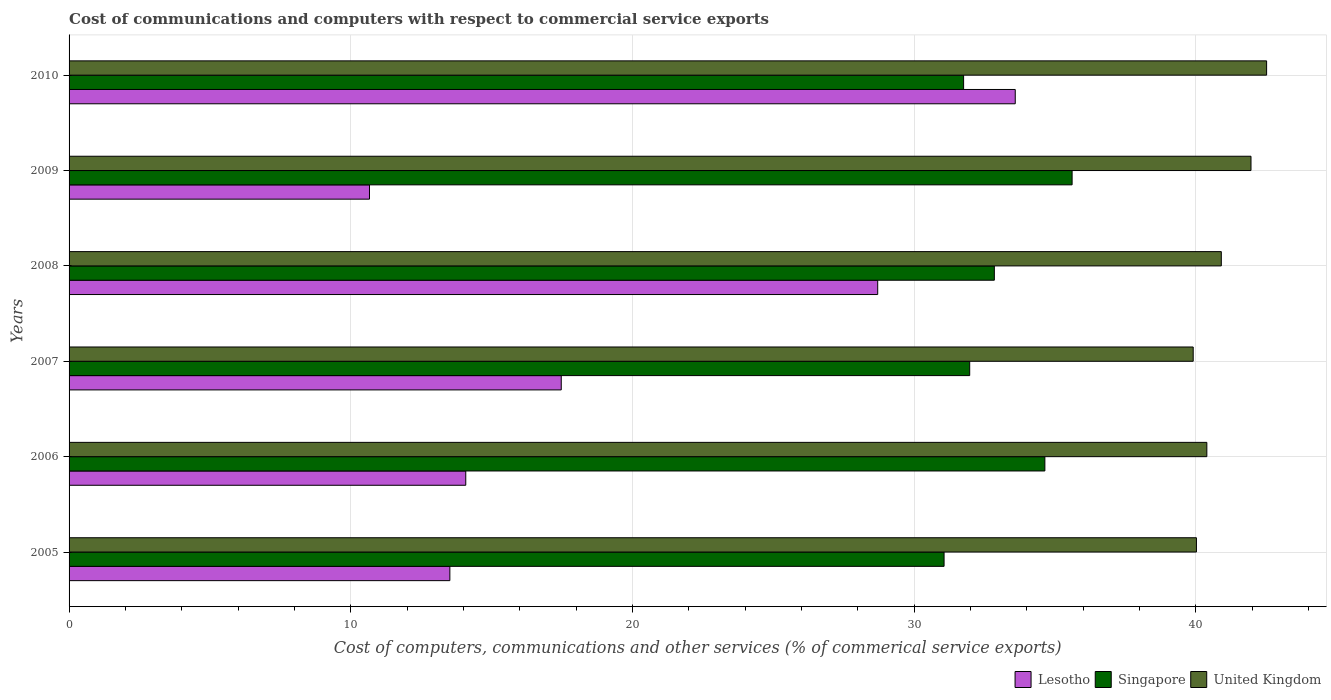How many groups of bars are there?
Your answer should be compact. 6. Are the number of bars on each tick of the Y-axis equal?
Ensure brevity in your answer.  Yes. What is the label of the 4th group of bars from the top?
Offer a terse response. 2007. What is the cost of communications and computers in United Kingdom in 2006?
Your answer should be compact. 40.39. Across all years, what is the maximum cost of communications and computers in Lesotho?
Give a very brief answer. 33.59. Across all years, what is the minimum cost of communications and computers in United Kingdom?
Your response must be concise. 39.91. In which year was the cost of communications and computers in United Kingdom minimum?
Provide a succinct answer. 2007. What is the total cost of communications and computers in Singapore in the graph?
Make the answer very short. 197.91. What is the difference between the cost of communications and computers in United Kingdom in 2007 and that in 2008?
Your response must be concise. -1. What is the difference between the cost of communications and computers in United Kingdom in 2005 and the cost of communications and computers in Singapore in 2008?
Make the answer very short. 7.17. What is the average cost of communications and computers in Lesotho per year?
Provide a succinct answer. 19.67. In the year 2007, what is the difference between the cost of communications and computers in United Kingdom and cost of communications and computers in Singapore?
Give a very brief answer. 7.93. In how many years, is the cost of communications and computers in Singapore greater than 16 %?
Offer a terse response. 6. What is the ratio of the cost of communications and computers in Singapore in 2005 to that in 2007?
Provide a short and direct response. 0.97. Is the cost of communications and computers in Lesotho in 2007 less than that in 2010?
Give a very brief answer. Yes. Is the difference between the cost of communications and computers in United Kingdom in 2007 and 2008 greater than the difference between the cost of communications and computers in Singapore in 2007 and 2008?
Make the answer very short. No. What is the difference between the highest and the second highest cost of communications and computers in Singapore?
Provide a short and direct response. 0.97. What is the difference between the highest and the lowest cost of communications and computers in Singapore?
Offer a terse response. 4.55. What does the 3rd bar from the top in 2008 represents?
Your answer should be very brief. Lesotho. What does the 3rd bar from the bottom in 2007 represents?
Offer a very short reply. United Kingdom. How many years are there in the graph?
Your response must be concise. 6. What is the difference between two consecutive major ticks on the X-axis?
Your answer should be very brief. 10. Are the values on the major ticks of X-axis written in scientific E-notation?
Make the answer very short. No. Does the graph contain any zero values?
Offer a terse response. No. Where does the legend appear in the graph?
Offer a very short reply. Bottom right. How are the legend labels stacked?
Your response must be concise. Horizontal. What is the title of the graph?
Provide a succinct answer. Cost of communications and computers with respect to commercial service exports. What is the label or title of the X-axis?
Your answer should be very brief. Cost of computers, communications and other services (% of commerical service exports). What is the label or title of the Y-axis?
Your response must be concise. Years. What is the Cost of computers, communications and other services (% of commerical service exports) of Lesotho in 2005?
Your response must be concise. 13.52. What is the Cost of computers, communications and other services (% of commerical service exports) of Singapore in 2005?
Provide a short and direct response. 31.07. What is the Cost of computers, communications and other services (% of commerical service exports) in United Kingdom in 2005?
Offer a very short reply. 40.03. What is the Cost of computers, communications and other services (% of commerical service exports) in Lesotho in 2006?
Your response must be concise. 14.08. What is the Cost of computers, communications and other services (% of commerical service exports) in Singapore in 2006?
Ensure brevity in your answer.  34.64. What is the Cost of computers, communications and other services (% of commerical service exports) of United Kingdom in 2006?
Make the answer very short. 40.39. What is the Cost of computers, communications and other services (% of commerical service exports) in Lesotho in 2007?
Provide a short and direct response. 17.47. What is the Cost of computers, communications and other services (% of commerical service exports) in Singapore in 2007?
Offer a terse response. 31.98. What is the Cost of computers, communications and other services (% of commerical service exports) in United Kingdom in 2007?
Your answer should be compact. 39.91. What is the Cost of computers, communications and other services (% of commerical service exports) in Lesotho in 2008?
Offer a terse response. 28.71. What is the Cost of computers, communications and other services (% of commerical service exports) in Singapore in 2008?
Offer a very short reply. 32.85. What is the Cost of computers, communications and other services (% of commerical service exports) of United Kingdom in 2008?
Keep it short and to the point. 40.91. What is the Cost of computers, communications and other services (% of commerical service exports) in Lesotho in 2009?
Offer a terse response. 10.67. What is the Cost of computers, communications and other services (% of commerical service exports) in Singapore in 2009?
Ensure brevity in your answer.  35.61. What is the Cost of computers, communications and other services (% of commerical service exports) of United Kingdom in 2009?
Provide a succinct answer. 41.96. What is the Cost of computers, communications and other services (% of commerical service exports) in Lesotho in 2010?
Give a very brief answer. 33.59. What is the Cost of computers, communications and other services (% of commerical service exports) in Singapore in 2010?
Provide a short and direct response. 31.76. What is the Cost of computers, communications and other services (% of commerical service exports) of United Kingdom in 2010?
Ensure brevity in your answer.  42.52. Across all years, what is the maximum Cost of computers, communications and other services (% of commerical service exports) of Lesotho?
Give a very brief answer. 33.59. Across all years, what is the maximum Cost of computers, communications and other services (% of commerical service exports) of Singapore?
Offer a terse response. 35.61. Across all years, what is the maximum Cost of computers, communications and other services (% of commerical service exports) in United Kingdom?
Your answer should be compact. 42.52. Across all years, what is the minimum Cost of computers, communications and other services (% of commerical service exports) in Lesotho?
Ensure brevity in your answer.  10.67. Across all years, what is the minimum Cost of computers, communications and other services (% of commerical service exports) in Singapore?
Make the answer very short. 31.07. Across all years, what is the minimum Cost of computers, communications and other services (% of commerical service exports) of United Kingdom?
Ensure brevity in your answer.  39.91. What is the total Cost of computers, communications and other services (% of commerical service exports) in Lesotho in the graph?
Offer a very short reply. 118.04. What is the total Cost of computers, communications and other services (% of commerical service exports) in Singapore in the graph?
Give a very brief answer. 197.91. What is the total Cost of computers, communications and other services (% of commerical service exports) of United Kingdom in the graph?
Provide a succinct answer. 245.72. What is the difference between the Cost of computers, communications and other services (% of commerical service exports) of Lesotho in 2005 and that in 2006?
Give a very brief answer. -0.56. What is the difference between the Cost of computers, communications and other services (% of commerical service exports) in Singapore in 2005 and that in 2006?
Ensure brevity in your answer.  -3.58. What is the difference between the Cost of computers, communications and other services (% of commerical service exports) in United Kingdom in 2005 and that in 2006?
Ensure brevity in your answer.  -0.37. What is the difference between the Cost of computers, communications and other services (% of commerical service exports) of Lesotho in 2005 and that in 2007?
Provide a succinct answer. -3.95. What is the difference between the Cost of computers, communications and other services (% of commerical service exports) of Singapore in 2005 and that in 2007?
Keep it short and to the point. -0.91. What is the difference between the Cost of computers, communications and other services (% of commerical service exports) of United Kingdom in 2005 and that in 2007?
Ensure brevity in your answer.  0.12. What is the difference between the Cost of computers, communications and other services (% of commerical service exports) in Lesotho in 2005 and that in 2008?
Make the answer very short. -15.19. What is the difference between the Cost of computers, communications and other services (% of commerical service exports) of Singapore in 2005 and that in 2008?
Give a very brief answer. -1.78. What is the difference between the Cost of computers, communications and other services (% of commerical service exports) of United Kingdom in 2005 and that in 2008?
Provide a short and direct response. -0.88. What is the difference between the Cost of computers, communications and other services (% of commerical service exports) in Lesotho in 2005 and that in 2009?
Your answer should be very brief. 2.85. What is the difference between the Cost of computers, communications and other services (% of commerical service exports) in Singapore in 2005 and that in 2009?
Provide a succinct answer. -4.55. What is the difference between the Cost of computers, communications and other services (% of commerical service exports) of United Kingdom in 2005 and that in 2009?
Keep it short and to the point. -1.94. What is the difference between the Cost of computers, communications and other services (% of commerical service exports) in Lesotho in 2005 and that in 2010?
Provide a short and direct response. -20.07. What is the difference between the Cost of computers, communications and other services (% of commerical service exports) of Singapore in 2005 and that in 2010?
Ensure brevity in your answer.  -0.69. What is the difference between the Cost of computers, communications and other services (% of commerical service exports) of United Kingdom in 2005 and that in 2010?
Offer a terse response. -2.49. What is the difference between the Cost of computers, communications and other services (% of commerical service exports) in Lesotho in 2006 and that in 2007?
Give a very brief answer. -3.39. What is the difference between the Cost of computers, communications and other services (% of commerical service exports) of Singapore in 2006 and that in 2007?
Offer a very short reply. 2.67. What is the difference between the Cost of computers, communications and other services (% of commerical service exports) of United Kingdom in 2006 and that in 2007?
Provide a succinct answer. 0.48. What is the difference between the Cost of computers, communications and other services (% of commerical service exports) of Lesotho in 2006 and that in 2008?
Your response must be concise. -14.62. What is the difference between the Cost of computers, communications and other services (% of commerical service exports) in Singapore in 2006 and that in 2008?
Your answer should be very brief. 1.79. What is the difference between the Cost of computers, communications and other services (% of commerical service exports) of United Kingdom in 2006 and that in 2008?
Offer a very short reply. -0.51. What is the difference between the Cost of computers, communications and other services (% of commerical service exports) of Lesotho in 2006 and that in 2009?
Give a very brief answer. 3.42. What is the difference between the Cost of computers, communications and other services (% of commerical service exports) of Singapore in 2006 and that in 2009?
Ensure brevity in your answer.  -0.97. What is the difference between the Cost of computers, communications and other services (% of commerical service exports) of United Kingdom in 2006 and that in 2009?
Your answer should be compact. -1.57. What is the difference between the Cost of computers, communications and other services (% of commerical service exports) in Lesotho in 2006 and that in 2010?
Keep it short and to the point. -19.51. What is the difference between the Cost of computers, communications and other services (% of commerical service exports) in Singapore in 2006 and that in 2010?
Your answer should be compact. 2.89. What is the difference between the Cost of computers, communications and other services (% of commerical service exports) in United Kingdom in 2006 and that in 2010?
Offer a very short reply. -2.12. What is the difference between the Cost of computers, communications and other services (% of commerical service exports) in Lesotho in 2007 and that in 2008?
Offer a terse response. -11.24. What is the difference between the Cost of computers, communications and other services (% of commerical service exports) of Singapore in 2007 and that in 2008?
Give a very brief answer. -0.88. What is the difference between the Cost of computers, communications and other services (% of commerical service exports) of United Kingdom in 2007 and that in 2008?
Provide a succinct answer. -1. What is the difference between the Cost of computers, communications and other services (% of commerical service exports) in Lesotho in 2007 and that in 2009?
Offer a terse response. 6.81. What is the difference between the Cost of computers, communications and other services (% of commerical service exports) of Singapore in 2007 and that in 2009?
Offer a very short reply. -3.64. What is the difference between the Cost of computers, communications and other services (% of commerical service exports) in United Kingdom in 2007 and that in 2009?
Provide a short and direct response. -2.05. What is the difference between the Cost of computers, communications and other services (% of commerical service exports) in Lesotho in 2007 and that in 2010?
Ensure brevity in your answer.  -16.12. What is the difference between the Cost of computers, communications and other services (% of commerical service exports) in Singapore in 2007 and that in 2010?
Your answer should be very brief. 0.22. What is the difference between the Cost of computers, communications and other services (% of commerical service exports) of United Kingdom in 2007 and that in 2010?
Provide a succinct answer. -2.61. What is the difference between the Cost of computers, communications and other services (% of commerical service exports) in Lesotho in 2008 and that in 2009?
Offer a terse response. 18.04. What is the difference between the Cost of computers, communications and other services (% of commerical service exports) in Singapore in 2008 and that in 2009?
Your response must be concise. -2.76. What is the difference between the Cost of computers, communications and other services (% of commerical service exports) in United Kingdom in 2008 and that in 2009?
Keep it short and to the point. -1.05. What is the difference between the Cost of computers, communications and other services (% of commerical service exports) of Lesotho in 2008 and that in 2010?
Provide a short and direct response. -4.88. What is the difference between the Cost of computers, communications and other services (% of commerical service exports) of Singapore in 2008 and that in 2010?
Your response must be concise. 1.09. What is the difference between the Cost of computers, communications and other services (% of commerical service exports) of United Kingdom in 2008 and that in 2010?
Your answer should be compact. -1.61. What is the difference between the Cost of computers, communications and other services (% of commerical service exports) of Lesotho in 2009 and that in 2010?
Keep it short and to the point. -22.93. What is the difference between the Cost of computers, communications and other services (% of commerical service exports) in Singapore in 2009 and that in 2010?
Your response must be concise. 3.85. What is the difference between the Cost of computers, communications and other services (% of commerical service exports) of United Kingdom in 2009 and that in 2010?
Offer a terse response. -0.55. What is the difference between the Cost of computers, communications and other services (% of commerical service exports) of Lesotho in 2005 and the Cost of computers, communications and other services (% of commerical service exports) of Singapore in 2006?
Give a very brief answer. -21.13. What is the difference between the Cost of computers, communications and other services (% of commerical service exports) in Lesotho in 2005 and the Cost of computers, communications and other services (% of commerical service exports) in United Kingdom in 2006?
Offer a very short reply. -26.88. What is the difference between the Cost of computers, communications and other services (% of commerical service exports) of Singapore in 2005 and the Cost of computers, communications and other services (% of commerical service exports) of United Kingdom in 2006?
Your answer should be compact. -9.33. What is the difference between the Cost of computers, communications and other services (% of commerical service exports) in Lesotho in 2005 and the Cost of computers, communications and other services (% of commerical service exports) in Singapore in 2007?
Provide a succinct answer. -18.46. What is the difference between the Cost of computers, communications and other services (% of commerical service exports) of Lesotho in 2005 and the Cost of computers, communications and other services (% of commerical service exports) of United Kingdom in 2007?
Offer a very short reply. -26.39. What is the difference between the Cost of computers, communications and other services (% of commerical service exports) of Singapore in 2005 and the Cost of computers, communications and other services (% of commerical service exports) of United Kingdom in 2007?
Provide a short and direct response. -8.84. What is the difference between the Cost of computers, communications and other services (% of commerical service exports) of Lesotho in 2005 and the Cost of computers, communications and other services (% of commerical service exports) of Singapore in 2008?
Make the answer very short. -19.33. What is the difference between the Cost of computers, communications and other services (% of commerical service exports) in Lesotho in 2005 and the Cost of computers, communications and other services (% of commerical service exports) in United Kingdom in 2008?
Your answer should be very brief. -27.39. What is the difference between the Cost of computers, communications and other services (% of commerical service exports) in Singapore in 2005 and the Cost of computers, communications and other services (% of commerical service exports) in United Kingdom in 2008?
Your answer should be compact. -9.84. What is the difference between the Cost of computers, communications and other services (% of commerical service exports) of Lesotho in 2005 and the Cost of computers, communications and other services (% of commerical service exports) of Singapore in 2009?
Make the answer very short. -22.09. What is the difference between the Cost of computers, communications and other services (% of commerical service exports) of Lesotho in 2005 and the Cost of computers, communications and other services (% of commerical service exports) of United Kingdom in 2009?
Provide a succinct answer. -28.44. What is the difference between the Cost of computers, communications and other services (% of commerical service exports) in Singapore in 2005 and the Cost of computers, communications and other services (% of commerical service exports) in United Kingdom in 2009?
Provide a short and direct response. -10.9. What is the difference between the Cost of computers, communications and other services (% of commerical service exports) of Lesotho in 2005 and the Cost of computers, communications and other services (% of commerical service exports) of Singapore in 2010?
Make the answer very short. -18.24. What is the difference between the Cost of computers, communications and other services (% of commerical service exports) in Lesotho in 2005 and the Cost of computers, communications and other services (% of commerical service exports) in United Kingdom in 2010?
Make the answer very short. -29. What is the difference between the Cost of computers, communications and other services (% of commerical service exports) of Singapore in 2005 and the Cost of computers, communications and other services (% of commerical service exports) of United Kingdom in 2010?
Make the answer very short. -11.45. What is the difference between the Cost of computers, communications and other services (% of commerical service exports) in Lesotho in 2006 and the Cost of computers, communications and other services (% of commerical service exports) in Singapore in 2007?
Make the answer very short. -17.89. What is the difference between the Cost of computers, communications and other services (% of commerical service exports) in Lesotho in 2006 and the Cost of computers, communications and other services (% of commerical service exports) in United Kingdom in 2007?
Your answer should be very brief. -25.83. What is the difference between the Cost of computers, communications and other services (% of commerical service exports) in Singapore in 2006 and the Cost of computers, communications and other services (% of commerical service exports) in United Kingdom in 2007?
Ensure brevity in your answer.  -5.27. What is the difference between the Cost of computers, communications and other services (% of commerical service exports) of Lesotho in 2006 and the Cost of computers, communications and other services (% of commerical service exports) of Singapore in 2008?
Your answer should be very brief. -18.77. What is the difference between the Cost of computers, communications and other services (% of commerical service exports) in Lesotho in 2006 and the Cost of computers, communications and other services (% of commerical service exports) in United Kingdom in 2008?
Provide a succinct answer. -26.82. What is the difference between the Cost of computers, communications and other services (% of commerical service exports) of Singapore in 2006 and the Cost of computers, communications and other services (% of commerical service exports) of United Kingdom in 2008?
Your answer should be very brief. -6.26. What is the difference between the Cost of computers, communications and other services (% of commerical service exports) in Lesotho in 2006 and the Cost of computers, communications and other services (% of commerical service exports) in Singapore in 2009?
Your response must be concise. -21.53. What is the difference between the Cost of computers, communications and other services (% of commerical service exports) in Lesotho in 2006 and the Cost of computers, communications and other services (% of commerical service exports) in United Kingdom in 2009?
Ensure brevity in your answer.  -27.88. What is the difference between the Cost of computers, communications and other services (% of commerical service exports) in Singapore in 2006 and the Cost of computers, communications and other services (% of commerical service exports) in United Kingdom in 2009?
Offer a terse response. -7.32. What is the difference between the Cost of computers, communications and other services (% of commerical service exports) of Lesotho in 2006 and the Cost of computers, communications and other services (% of commerical service exports) of Singapore in 2010?
Provide a short and direct response. -17.68. What is the difference between the Cost of computers, communications and other services (% of commerical service exports) in Lesotho in 2006 and the Cost of computers, communications and other services (% of commerical service exports) in United Kingdom in 2010?
Offer a very short reply. -28.43. What is the difference between the Cost of computers, communications and other services (% of commerical service exports) of Singapore in 2006 and the Cost of computers, communications and other services (% of commerical service exports) of United Kingdom in 2010?
Your answer should be very brief. -7.87. What is the difference between the Cost of computers, communications and other services (% of commerical service exports) in Lesotho in 2007 and the Cost of computers, communications and other services (% of commerical service exports) in Singapore in 2008?
Your answer should be very brief. -15.38. What is the difference between the Cost of computers, communications and other services (% of commerical service exports) in Lesotho in 2007 and the Cost of computers, communications and other services (% of commerical service exports) in United Kingdom in 2008?
Keep it short and to the point. -23.43. What is the difference between the Cost of computers, communications and other services (% of commerical service exports) of Singapore in 2007 and the Cost of computers, communications and other services (% of commerical service exports) of United Kingdom in 2008?
Ensure brevity in your answer.  -8.93. What is the difference between the Cost of computers, communications and other services (% of commerical service exports) of Lesotho in 2007 and the Cost of computers, communications and other services (% of commerical service exports) of Singapore in 2009?
Ensure brevity in your answer.  -18.14. What is the difference between the Cost of computers, communications and other services (% of commerical service exports) of Lesotho in 2007 and the Cost of computers, communications and other services (% of commerical service exports) of United Kingdom in 2009?
Your answer should be compact. -24.49. What is the difference between the Cost of computers, communications and other services (% of commerical service exports) in Singapore in 2007 and the Cost of computers, communications and other services (% of commerical service exports) in United Kingdom in 2009?
Make the answer very short. -9.99. What is the difference between the Cost of computers, communications and other services (% of commerical service exports) in Lesotho in 2007 and the Cost of computers, communications and other services (% of commerical service exports) in Singapore in 2010?
Your response must be concise. -14.29. What is the difference between the Cost of computers, communications and other services (% of commerical service exports) of Lesotho in 2007 and the Cost of computers, communications and other services (% of commerical service exports) of United Kingdom in 2010?
Your response must be concise. -25.04. What is the difference between the Cost of computers, communications and other services (% of commerical service exports) in Singapore in 2007 and the Cost of computers, communications and other services (% of commerical service exports) in United Kingdom in 2010?
Provide a succinct answer. -10.54. What is the difference between the Cost of computers, communications and other services (% of commerical service exports) of Lesotho in 2008 and the Cost of computers, communications and other services (% of commerical service exports) of Singapore in 2009?
Make the answer very short. -6.9. What is the difference between the Cost of computers, communications and other services (% of commerical service exports) in Lesotho in 2008 and the Cost of computers, communications and other services (% of commerical service exports) in United Kingdom in 2009?
Make the answer very short. -13.25. What is the difference between the Cost of computers, communications and other services (% of commerical service exports) of Singapore in 2008 and the Cost of computers, communications and other services (% of commerical service exports) of United Kingdom in 2009?
Provide a succinct answer. -9.11. What is the difference between the Cost of computers, communications and other services (% of commerical service exports) in Lesotho in 2008 and the Cost of computers, communications and other services (% of commerical service exports) in Singapore in 2010?
Your answer should be very brief. -3.05. What is the difference between the Cost of computers, communications and other services (% of commerical service exports) in Lesotho in 2008 and the Cost of computers, communications and other services (% of commerical service exports) in United Kingdom in 2010?
Provide a short and direct response. -13.81. What is the difference between the Cost of computers, communications and other services (% of commerical service exports) in Singapore in 2008 and the Cost of computers, communications and other services (% of commerical service exports) in United Kingdom in 2010?
Provide a succinct answer. -9.67. What is the difference between the Cost of computers, communications and other services (% of commerical service exports) of Lesotho in 2009 and the Cost of computers, communications and other services (% of commerical service exports) of Singapore in 2010?
Ensure brevity in your answer.  -21.09. What is the difference between the Cost of computers, communications and other services (% of commerical service exports) of Lesotho in 2009 and the Cost of computers, communications and other services (% of commerical service exports) of United Kingdom in 2010?
Your answer should be compact. -31.85. What is the difference between the Cost of computers, communications and other services (% of commerical service exports) in Singapore in 2009 and the Cost of computers, communications and other services (% of commerical service exports) in United Kingdom in 2010?
Provide a succinct answer. -6.91. What is the average Cost of computers, communications and other services (% of commerical service exports) in Lesotho per year?
Your answer should be very brief. 19.67. What is the average Cost of computers, communications and other services (% of commerical service exports) in Singapore per year?
Make the answer very short. 32.98. What is the average Cost of computers, communications and other services (% of commerical service exports) of United Kingdom per year?
Offer a terse response. 40.95. In the year 2005, what is the difference between the Cost of computers, communications and other services (% of commerical service exports) of Lesotho and Cost of computers, communications and other services (% of commerical service exports) of Singapore?
Your answer should be compact. -17.55. In the year 2005, what is the difference between the Cost of computers, communications and other services (% of commerical service exports) of Lesotho and Cost of computers, communications and other services (% of commerical service exports) of United Kingdom?
Provide a succinct answer. -26.51. In the year 2005, what is the difference between the Cost of computers, communications and other services (% of commerical service exports) in Singapore and Cost of computers, communications and other services (% of commerical service exports) in United Kingdom?
Provide a short and direct response. -8.96. In the year 2006, what is the difference between the Cost of computers, communications and other services (% of commerical service exports) of Lesotho and Cost of computers, communications and other services (% of commerical service exports) of Singapore?
Make the answer very short. -20.56. In the year 2006, what is the difference between the Cost of computers, communications and other services (% of commerical service exports) of Lesotho and Cost of computers, communications and other services (% of commerical service exports) of United Kingdom?
Offer a very short reply. -26.31. In the year 2006, what is the difference between the Cost of computers, communications and other services (% of commerical service exports) in Singapore and Cost of computers, communications and other services (% of commerical service exports) in United Kingdom?
Make the answer very short. -5.75. In the year 2007, what is the difference between the Cost of computers, communications and other services (% of commerical service exports) of Lesotho and Cost of computers, communications and other services (% of commerical service exports) of Singapore?
Keep it short and to the point. -14.5. In the year 2007, what is the difference between the Cost of computers, communications and other services (% of commerical service exports) in Lesotho and Cost of computers, communications and other services (% of commerical service exports) in United Kingdom?
Give a very brief answer. -22.44. In the year 2007, what is the difference between the Cost of computers, communications and other services (% of commerical service exports) of Singapore and Cost of computers, communications and other services (% of commerical service exports) of United Kingdom?
Your response must be concise. -7.93. In the year 2008, what is the difference between the Cost of computers, communications and other services (% of commerical service exports) in Lesotho and Cost of computers, communications and other services (% of commerical service exports) in Singapore?
Make the answer very short. -4.14. In the year 2008, what is the difference between the Cost of computers, communications and other services (% of commerical service exports) in Lesotho and Cost of computers, communications and other services (% of commerical service exports) in United Kingdom?
Make the answer very short. -12.2. In the year 2008, what is the difference between the Cost of computers, communications and other services (% of commerical service exports) in Singapore and Cost of computers, communications and other services (% of commerical service exports) in United Kingdom?
Give a very brief answer. -8.06. In the year 2009, what is the difference between the Cost of computers, communications and other services (% of commerical service exports) in Lesotho and Cost of computers, communications and other services (% of commerical service exports) in Singapore?
Offer a very short reply. -24.95. In the year 2009, what is the difference between the Cost of computers, communications and other services (% of commerical service exports) of Lesotho and Cost of computers, communications and other services (% of commerical service exports) of United Kingdom?
Keep it short and to the point. -31.3. In the year 2009, what is the difference between the Cost of computers, communications and other services (% of commerical service exports) in Singapore and Cost of computers, communications and other services (% of commerical service exports) in United Kingdom?
Offer a very short reply. -6.35. In the year 2010, what is the difference between the Cost of computers, communications and other services (% of commerical service exports) of Lesotho and Cost of computers, communications and other services (% of commerical service exports) of Singapore?
Offer a very short reply. 1.83. In the year 2010, what is the difference between the Cost of computers, communications and other services (% of commerical service exports) in Lesotho and Cost of computers, communications and other services (% of commerical service exports) in United Kingdom?
Provide a succinct answer. -8.92. In the year 2010, what is the difference between the Cost of computers, communications and other services (% of commerical service exports) of Singapore and Cost of computers, communications and other services (% of commerical service exports) of United Kingdom?
Ensure brevity in your answer.  -10.76. What is the ratio of the Cost of computers, communications and other services (% of commerical service exports) in Lesotho in 2005 to that in 2006?
Provide a short and direct response. 0.96. What is the ratio of the Cost of computers, communications and other services (% of commerical service exports) in Singapore in 2005 to that in 2006?
Your answer should be compact. 0.9. What is the ratio of the Cost of computers, communications and other services (% of commerical service exports) in United Kingdom in 2005 to that in 2006?
Offer a terse response. 0.99. What is the ratio of the Cost of computers, communications and other services (% of commerical service exports) in Lesotho in 2005 to that in 2007?
Keep it short and to the point. 0.77. What is the ratio of the Cost of computers, communications and other services (% of commerical service exports) in Singapore in 2005 to that in 2007?
Your answer should be very brief. 0.97. What is the ratio of the Cost of computers, communications and other services (% of commerical service exports) of United Kingdom in 2005 to that in 2007?
Provide a succinct answer. 1. What is the ratio of the Cost of computers, communications and other services (% of commerical service exports) of Lesotho in 2005 to that in 2008?
Ensure brevity in your answer.  0.47. What is the ratio of the Cost of computers, communications and other services (% of commerical service exports) in Singapore in 2005 to that in 2008?
Keep it short and to the point. 0.95. What is the ratio of the Cost of computers, communications and other services (% of commerical service exports) of United Kingdom in 2005 to that in 2008?
Keep it short and to the point. 0.98. What is the ratio of the Cost of computers, communications and other services (% of commerical service exports) in Lesotho in 2005 to that in 2009?
Ensure brevity in your answer.  1.27. What is the ratio of the Cost of computers, communications and other services (% of commerical service exports) of Singapore in 2005 to that in 2009?
Provide a short and direct response. 0.87. What is the ratio of the Cost of computers, communications and other services (% of commerical service exports) in United Kingdom in 2005 to that in 2009?
Give a very brief answer. 0.95. What is the ratio of the Cost of computers, communications and other services (% of commerical service exports) of Lesotho in 2005 to that in 2010?
Keep it short and to the point. 0.4. What is the ratio of the Cost of computers, communications and other services (% of commerical service exports) in Singapore in 2005 to that in 2010?
Your response must be concise. 0.98. What is the ratio of the Cost of computers, communications and other services (% of commerical service exports) in United Kingdom in 2005 to that in 2010?
Provide a succinct answer. 0.94. What is the ratio of the Cost of computers, communications and other services (% of commerical service exports) in Lesotho in 2006 to that in 2007?
Ensure brevity in your answer.  0.81. What is the ratio of the Cost of computers, communications and other services (% of commerical service exports) in Singapore in 2006 to that in 2007?
Make the answer very short. 1.08. What is the ratio of the Cost of computers, communications and other services (% of commerical service exports) in United Kingdom in 2006 to that in 2007?
Your response must be concise. 1.01. What is the ratio of the Cost of computers, communications and other services (% of commerical service exports) of Lesotho in 2006 to that in 2008?
Your answer should be compact. 0.49. What is the ratio of the Cost of computers, communications and other services (% of commerical service exports) of Singapore in 2006 to that in 2008?
Ensure brevity in your answer.  1.05. What is the ratio of the Cost of computers, communications and other services (% of commerical service exports) in United Kingdom in 2006 to that in 2008?
Ensure brevity in your answer.  0.99. What is the ratio of the Cost of computers, communications and other services (% of commerical service exports) of Lesotho in 2006 to that in 2009?
Offer a terse response. 1.32. What is the ratio of the Cost of computers, communications and other services (% of commerical service exports) of Singapore in 2006 to that in 2009?
Your response must be concise. 0.97. What is the ratio of the Cost of computers, communications and other services (% of commerical service exports) of United Kingdom in 2006 to that in 2009?
Provide a short and direct response. 0.96. What is the ratio of the Cost of computers, communications and other services (% of commerical service exports) in Lesotho in 2006 to that in 2010?
Your response must be concise. 0.42. What is the ratio of the Cost of computers, communications and other services (% of commerical service exports) in Singapore in 2006 to that in 2010?
Provide a succinct answer. 1.09. What is the ratio of the Cost of computers, communications and other services (% of commerical service exports) of United Kingdom in 2006 to that in 2010?
Offer a very short reply. 0.95. What is the ratio of the Cost of computers, communications and other services (% of commerical service exports) in Lesotho in 2007 to that in 2008?
Make the answer very short. 0.61. What is the ratio of the Cost of computers, communications and other services (% of commerical service exports) of Singapore in 2007 to that in 2008?
Offer a terse response. 0.97. What is the ratio of the Cost of computers, communications and other services (% of commerical service exports) in United Kingdom in 2007 to that in 2008?
Your response must be concise. 0.98. What is the ratio of the Cost of computers, communications and other services (% of commerical service exports) of Lesotho in 2007 to that in 2009?
Make the answer very short. 1.64. What is the ratio of the Cost of computers, communications and other services (% of commerical service exports) in Singapore in 2007 to that in 2009?
Provide a short and direct response. 0.9. What is the ratio of the Cost of computers, communications and other services (% of commerical service exports) in United Kingdom in 2007 to that in 2009?
Your response must be concise. 0.95. What is the ratio of the Cost of computers, communications and other services (% of commerical service exports) in Lesotho in 2007 to that in 2010?
Give a very brief answer. 0.52. What is the ratio of the Cost of computers, communications and other services (% of commerical service exports) of Singapore in 2007 to that in 2010?
Keep it short and to the point. 1.01. What is the ratio of the Cost of computers, communications and other services (% of commerical service exports) in United Kingdom in 2007 to that in 2010?
Your response must be concise. 0.94. What is the ratio of the Cost of computers, communications and other services (% of commerical service exports) in Lesotho in 2008 to that in 2009?
Your response must be concise. 2.69. What is the ratio of the Cost of computers, communications and other services (% of commerical service exports) of Singapore in 2008 to that in 2009?
Your response must be concise. 0.92. What is the ratio of the Cost of computers, communications and other services (% of commerical service exports) in United Kingdom in 2008 to that in 2009?
Offer a very short reply. 0.97. What is the ratio of the Cost of computers, communications and other services (% of commerical service exports) of Lesotho in 2008 to that in 2010?
Give a very brief answer. 0.85. What is the ratio of the Cost of computers, communications and other services (% of commerical service exports) in Singapore in 2008 to that in 2010?
Provide a succinct answer. 1.03. What is the ratio of the Cost of computers, communications and other services (% of commerical service exports) of United Kingdom in 2008 to that in 2010?
Your answer should be compact. 0.96. What is the ratio of the Cost of computers, communications and other services (% of commerical service exports) in Lesotho in 2009 to that in 2010?
Your answer should be compact. 0.32. What is the ratio of the Cost of computers, communications and other services (% of commerical service exports) in Singapore in 2009 to that in 2010?
Keep it short and to the point. 1.12. What is the ratio of the Cost of computers, communications and other services (% of commerical service exports) in United Kingdom in 2009 to that in 2010?
Provide a short and direct response. 0.99. What is the difference between the highest and the second highest Cost of computers, communications and other services (% of commerical service exports) in Lesotho?
Provide a succinct answer. 4.88. What is the difference between the highest and the second highest Cost of computers, communications and other services (% of commerical service exports) of Singapore?
Provide a short and direct response. 0.97. What is the difference between the highest and the second highest Cost of computers, communications and other services (% of commerical service exports) in United Kingdom?
Provide a short and direct response. 0.55. What is the difference between the highest and the lowest Cost of computers, communications and other services (% of commerical service exports) in Lesotho?
Keep it short and to the point. 22.93. What is the difference between the highest and the lowest Cost of computers, communications and other services (% of commerical service exports) in Singapore?
Give a very brief answer. 4.55. What is the difference between the highest and the lowest Cost of computers, communications and other services (% of commerical service exports) in United Kingdom?
Ensure brevity in your answer.  2.61. 